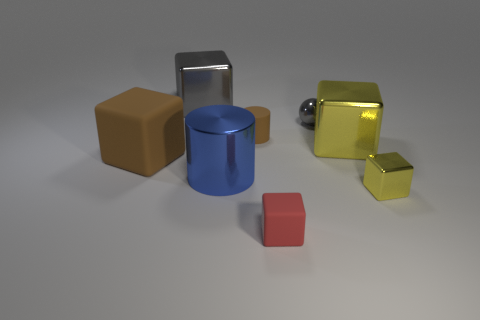What number of big things are in front of the small brown cylinder and right of the brown rubber block?
Your answer should be compact. 2. There is a matte object to the left of the large metallic cylinder; how many metallic spheres are to the right of it?
Your answer should be compact. 1. How many things are either gray things that are to the right of the tiny red object or big blocks on the left side of the small cylinder?
Provide a succinct answer. 3. What material is the other thing that is the same shape as the small brown matte thing?
Your answer should be compact. Metal. How many things are large objects right of the large gray metal thing or small cubes?
Provide a short and direct response. 4. What is the shape of the small yellow object that is made of the same material as the large cylinder?
Provide a succinct answer. Cube. How many small blue shiny objects have the same shape as the big brown object?
Your answer should be very brief. 0. What material is the tiny yellow cube?
Keep it short and to the point. Metal. There is a tiny metal block; is its color the same as the cube in front of the small yellow thing?
Offer a terse response. No. How many balls are small blue things or small red things?
Offer a terse response. 0. 